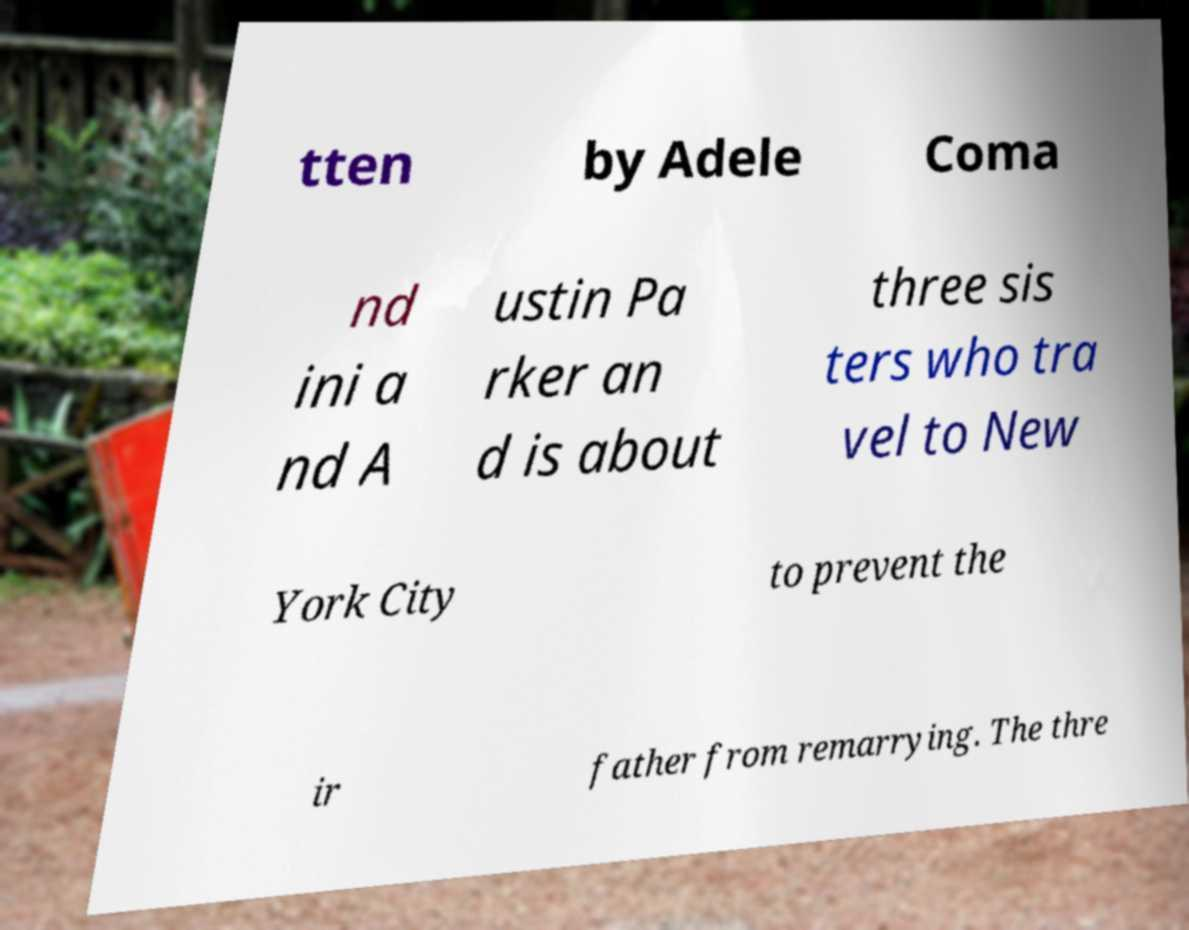Could you assist in decoding the text presented in this image and type it out clearly? tten by Adele Coma nd ini a nd A ustin Pa rker an d is about three sis ters who tra vel to New York City to prevent the ir father from remarrying. The thre 